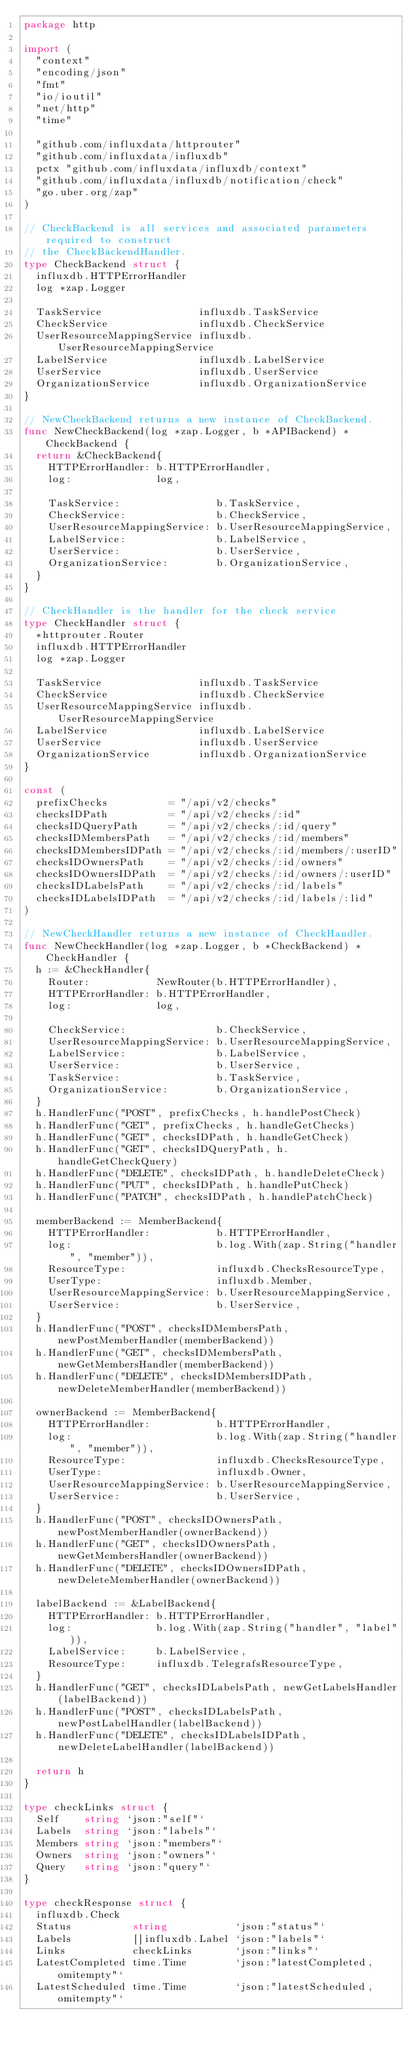<code> <loc_0><loc_0><loc_500><loc_500><_Go_>package http

import (
	"context"
	"encoding/json"
	"fmt"
	"io/ioutil"
	"net/http"
	"time"

	"github.com/influxdata/httprouter"
	"github.com/influxdata/influxdb"
	pctx "github.com/influxdata/influxdb/context"
	"github.com/influxdata/influxdb/notification/check"
	"go.uber.org/zap"
)

// CheckBackend is all services and associated parameters required to construct
// the CheckBackendHandler.
type CheckBackend struct {
	influxdb.HTTPErrorHandler
	log *zap.Logger

	TaskService                influxdb.TaskService
	CheckService               influxdb.CheckService
	UserResourceMappingService influxdb.UserResourceMappingService
	LabelService               influxdb.LabelService
	UserService                influxdb.UserService
	OrganizationService        influxdb.OrganizationService
}

// NewCheckBackend returns a new instance of CheckBackend.
func NewCheckBackend(log *zap.Logger, b *APIBackend) *CheckBackend {
	return &CheckBackend{
		HTTPErrorHandler: b.HTTPErrorHandler,
		log:              log,

		TaskService:                b.TaskService,
		CheckService:               b.CheckService,
		UserResourceMappingService: b.UserResourceMappingService,
		LabelService:               b.LabelService,
		UserService:                b.UserService,
		OrganizationService:        b.OrganizationService,
	}
}

// CheckHandler is the handler for the check service
type CheckHandler struct {
	*httprouter.Router
	influxdb.HTTPErrorHandler
	log *zap.Logger

	TaskService                influxdb.TaskService
	CheckService               influxdb.CheckService
	UserResourceMappingService influxdb.UserResourceMappingService
	LabelService               influxdb.LabelService
	UserService                influxdb.UserService
	OrganizationService        influxdb.OrganizationService
}

const (
	prefixChecks          = "/api/v2/checks"
	checksIDPath          = "/api/v2/checks/:id"
	checksIDQueryPath     = "/api/v2/checks/:id/query"
	checksIDMembersPath   = "/api/v2/checks/:id/members"
	checksIDMembersIDPath = "/api/v2/checks/:id/members/:userID"
	checksIDOwnersPath    = "/api/v2/checks/:id/owners"
	checksIDOwnersIDPath  = "/api/v2/checks/:id/owners/:userID"
	checksIDLabelsPath    = "/api/v2/checks/:id/labels"
	checksIDLabelsIDPath  = "/api/v2/checks/:id/labels/:lid"
)

// NewCheckHandler returns a new instance of CheckHandler.
func NewCheckHandler(log *zap.Logger, b *CheckBackend) *CheckHandler {
	h := &CheckHandler{
		Router:           NewRouter(b.HTTPErrorHandler),
		HTTPErrorHandler: b.HTTPErrorHandler,
		log:              log,

		CheckService:               b.CheckService,
		UserResourceMappingService: b.UserResourceMappingService,
		LabelService:               b.LabelService,
		UserService:                b.UserService,
		TaskService:                b.TaskService,
		OrganizationService:        b.OrganizationService,
	}
	h.HandlerFunc("POST", prefixChecks, h.handlePostCheck)
	h.HandlerFunc("GET", prefixChecks, h.handleGetChecks)
	h.HandlerFunc("GET", checksIDPath, h.handleGetCheck)
	h.HandlerFunc("GET", checksIDQueryPath, h.handleGetCheckQuery)
	h.HandlerFunc("DELETE", checksIDPath, h.handleDeleteCheck)
	h.HandlerFunc("PUT", checksIDPath, h.handlePutCheck)
	h.HandlerFunc("PATCH", checksIDPath, h.handlePatchCheck)

	memberBackend := MemberBackend{
		HTTPErrorHandler:           b.HTTPErrorHandler,
		log:                        b.log.With(zap.String("handler", "member")),
		ResourceType:               influxdb.ChecksResourceType,
		UserType:                   influxdb.Member,
		UserResourceMappingService: b.UserResourceMappingService,
		UserService:                b.UserService,
	}
	h.HandlerFunc("POST", checksIDMembersPath, newPostMemberHandler(memberBackend))
	h.HandlerFunc("GET", checksIDMembersPath, newGetMembersHandler(memberBackend))
	h.HandlerFunc("DELETE", checksIDMembersIDPath, newDeleteMemberHandler(memberBackend))

	ownerBackend := MemberBackend{
		HTTPErrorHandler:           b.HTTPErrorHandler,
		log:                        b.log.With(zap.String("handler", "member")),
		ResourceType:               influxdb.ChecksResourceType,
		UserType:                   influxdb.Owner,
		UserResourceMappingService: b.UserResourceMappingService,
		UserService:                b.UserService,
	}
	h.HandlerFunc("POST", checksIDOwnersPath, newPostMemberHandler(ownerBackend))
	h.HandlerFunc("GET", checksIDOwnersPath, newGetMembersHandler(ownerBackend))
	h.HandlerFunc("DELETE", checksIDOwnersIDPath, newDeleteMemberHandler(ownerBackend))

	labelBackend := &LabelBackend{
		HTTPErrorHandler: b.HTTPErrorHandler,
		log:              b.log.With(zap.String("handler", "label")),
		LabelService:     b.LabelService,
		ResourceType:     influxdb.TelegrafsResourceType,
	}
	h.HandlerFunc("GET", checksIDLabelsPath, newGetLabelsHandler(labelBackend))
	h.HandlerFunc("POST", checksIDLabelsPath, newPostLabelHandler(labelBackend))
	h.HandlerFunc("DELETE", checksIDLabelsIDPath, newDeleteLabelHandler(labelBackend))

	return h
}

type checkLinks struct {
	Self    string `json:"self"`
	Labels  string `json:"labels"`
	Members string `json:"members"`
	Owners  string `json:"owners"`
	Query   string `json:"query"`
}

type checkResponse struct {
	influxdb.Check
	Status          string           `json:"status"`
	Labels          []influxdb.Label `json:"labels"`
	Links           checkLinks       `json:"links"`
	LatestCompleted time.Time        `json:"latestCompleted,omitempty"`
	LatestScheduled time.Time        `json:"latestScheduled,omitempty"`</code> 